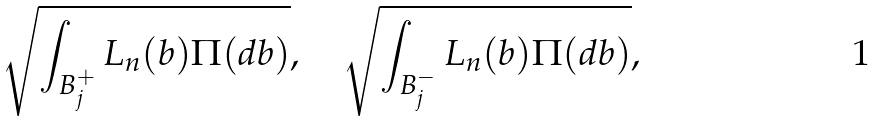Convert formula to latex. <formula><loc_0><loc_0><loc_500><loc_500>\sqrt { \int _ { B _ { j } ^ { + } } L _ { n } ( b ) \Pi ( d b ) } , \quad \sqrt { \int _ { B _ { j } ^ { - } } L _ { n } ( b ) \Pi ( d b ) } ,</formula> 